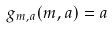Convert formula to latex. <formula><loc_0><loc_0><loc_500><loc_500>g _ { m , a } ( m , a ) = a</formula> 